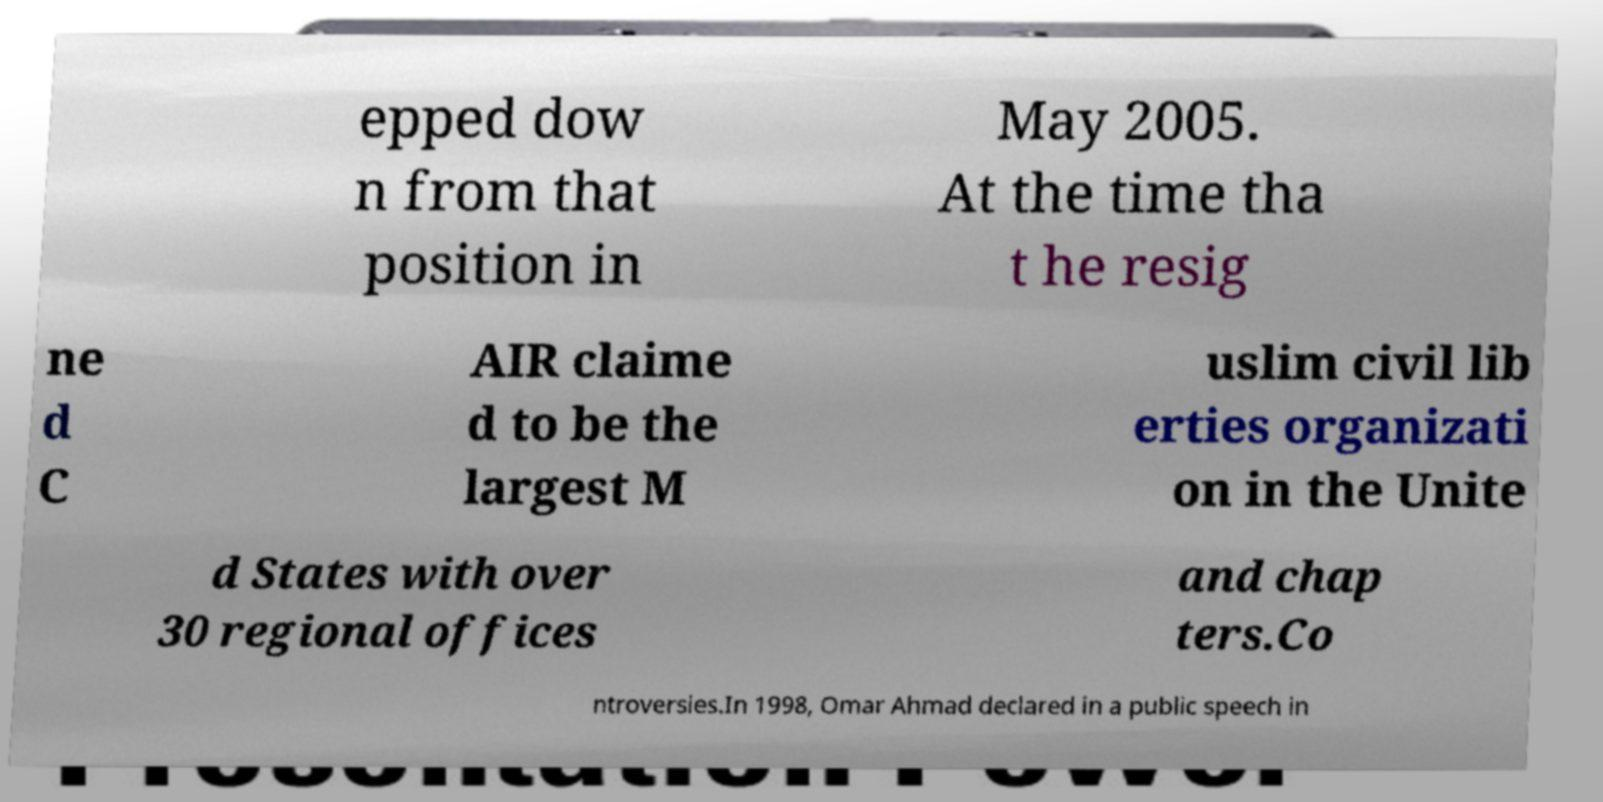What messages or text are displayed in this image? I need them in a readable, typed format. epped dow n from that position in May 2005. At the time tha t he resig ne d C AIR claime d to be the largest M uslim civil lib erties organizati on in the Unite d States with over 30 regional offices and chap ters.Co ntroversies.In 1998, Omar Ahmad declared in a public speech in 